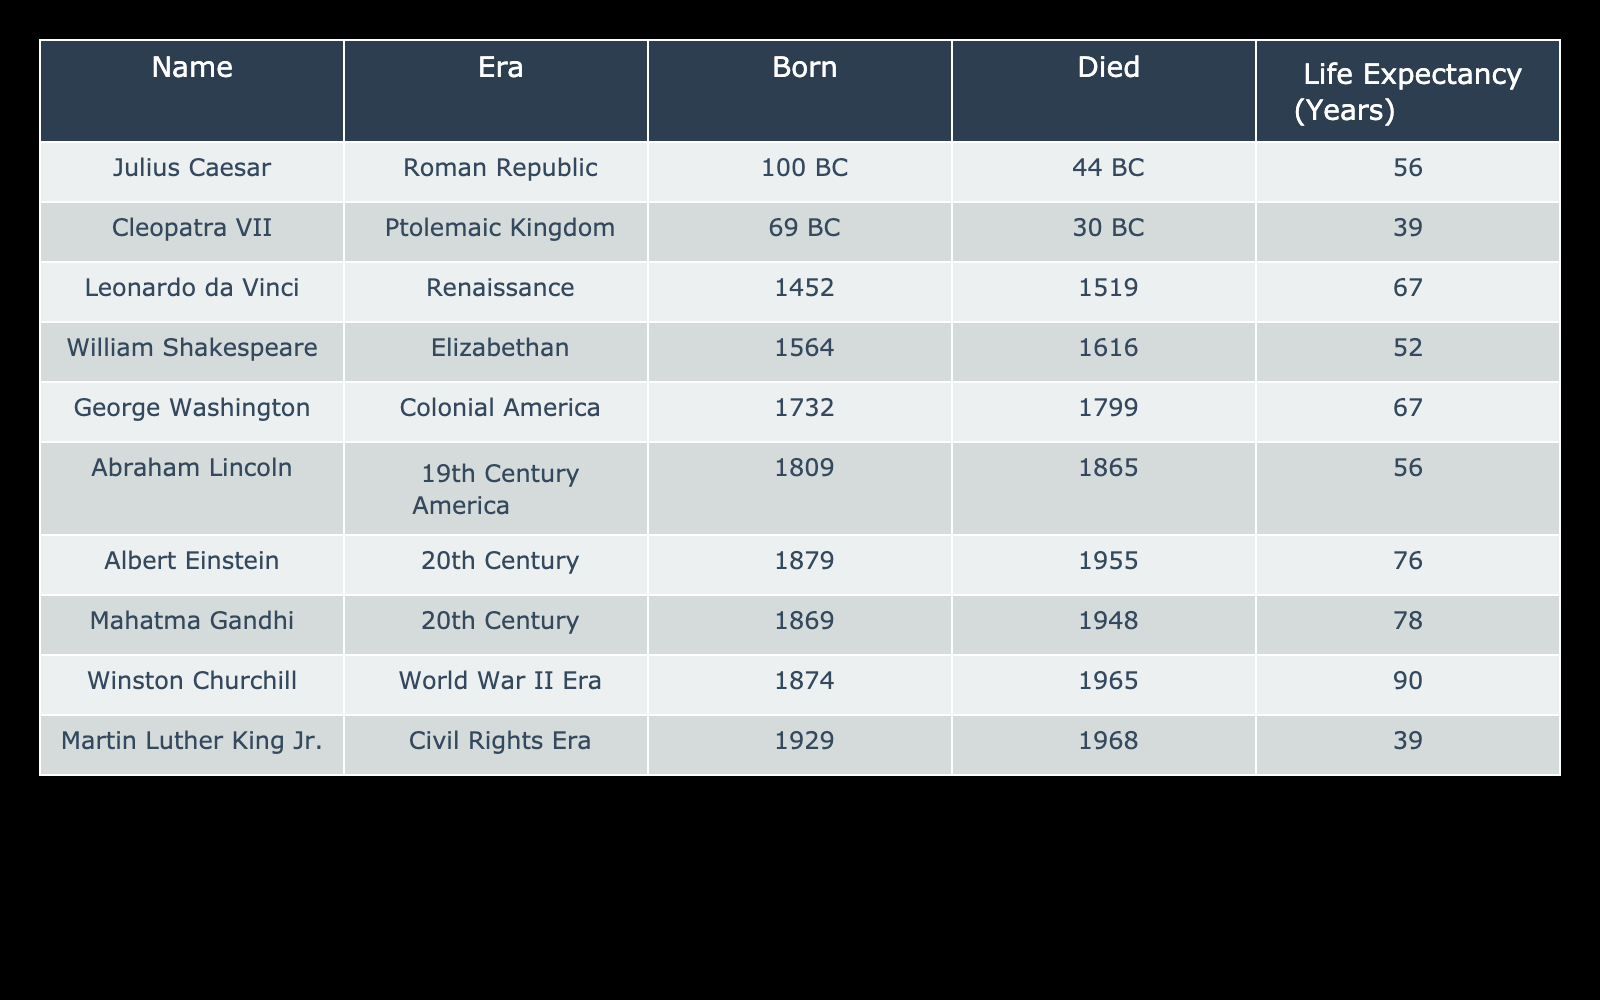What was the life expectancy of Julius Caesar? From the table, the life expectancy of Julius Caesar is stated directly in the corresponding row, which shows that he lived for 56 years.
Answer: 56 Which historical figure had the longest life expectancy? By examining the life expectancy values in the table, we see that Winston Churchill had the longest life expectancy at 90 years.
Answer: 90 Is Mahatma Gandhi's life expectancy greater than that of William Shakespeare? The table lists Mahatma Gandhi's life expectancy as 78 years and William Shakespeare's as 52 years. Since 78 is greater than 52, the answer to the question is yes.
Answer: Yes What is the average life expectancy of the historical figures from the 20th Century? For the 20th Century, we have two figures: Albert Einstein (76 years) and Mahatma Gandhi (78 years). To find the average, we add these two values: 76 + 78 = 154, then divide by the number of figures (2), which gives us 154 / 2 = 77.
Answer: 77 Did Cleopatra VII live longer than Martin Luther King Jr.? The table shows Cleopatra VII lived for 39 years and Martin Luther King Jr. lived for 39 years as well. Thus, they lived the same amount of time, which means Cleopatra did not live longer.
Answer: No How many historical figures had a life expectancy below 50 years? By reviewing the table, we see there are two figures with life expectancies below 50 years: Cleopatra VII (39 years) and Martin Luther King Jr. (39 years). Therefore, the total is 2 figures.
Answer: 2 What is the difference in life expectancy between George Washington and Abraham Lincoln? From the table, George Washington lived for 67 years, while Abraham Lincoln lived for 56 years. To find the difference, we subtract Lincoln's life expectancy from Washington's: 67 - 56 = 11 years.
Answer: 11 Which eras had life expectancies greater than 70 years? Analyzing the life expectancies in the table, we see that only Albert Einstein (76 years), Mahatma Gandhi (78 years), and Winston Churchill (90 years) had life expectancies greater than 70 years. Therefore, the eras are: 20th Century and World War II Era.
Answer: 2 eras What is the median life expectancy of the figures from the Renaissance and earlier? The figures from the Renaissance and earlier include: Julius Caesar (56), Cleopatra VII (39), Leonardo da Vinci (67), and William Shakespeare (52). Sorting these gives us: 39, 52, 56, 67. The median will be the average of the two middle values, which are 52 and 56. Adding them gives 108, and dividing by 2 gives us 54.
Answer: 54 